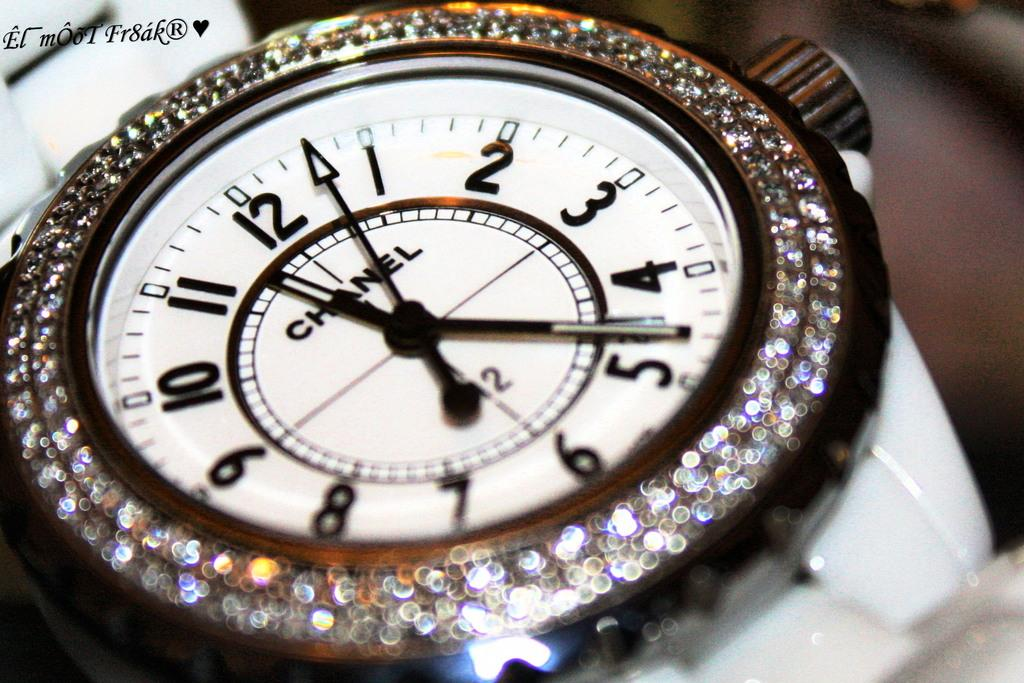Provide a one-sentence caption for the provided image. A Chanel watch has a white face surrounded by diamonds. 